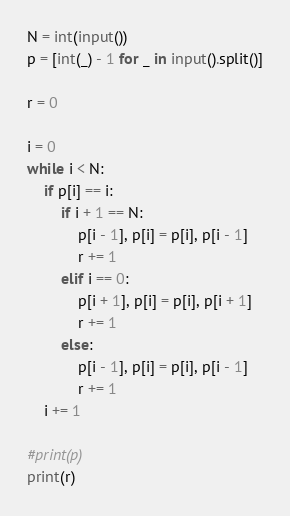Convert code to text. <code><loc_0><loc_0><loc_500><loc_500><_Python_>N = int(input())
p = [int(_) - 1 for _ in input().split()]

r = 0

i = 0
while i < N:
    if p[i] == i:
        if i + 1 == N:
            p[i - 1], p[i] = p[i], p[i - 1]
            r += 1
        elif i == 0:
            p[i + 1], p[i] = p[i], p[i + 1]
            r += 1
        else:
            p[i - 1], p[i] = p[i], p[i - 1]
            r += 1
    i += 1

#print(p)
print(r)
</code> 